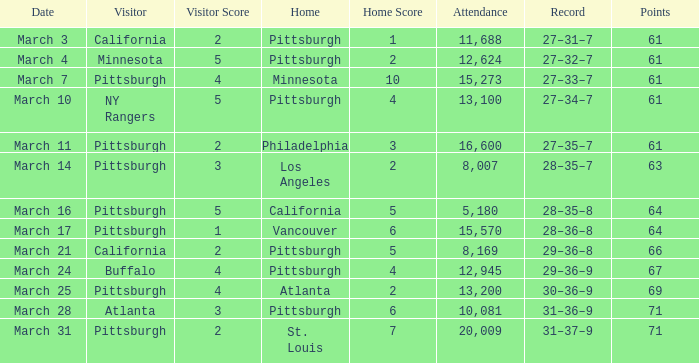What is the Score of the Pittsburgh Home game on March 3 with 61 Points? 2–1. 